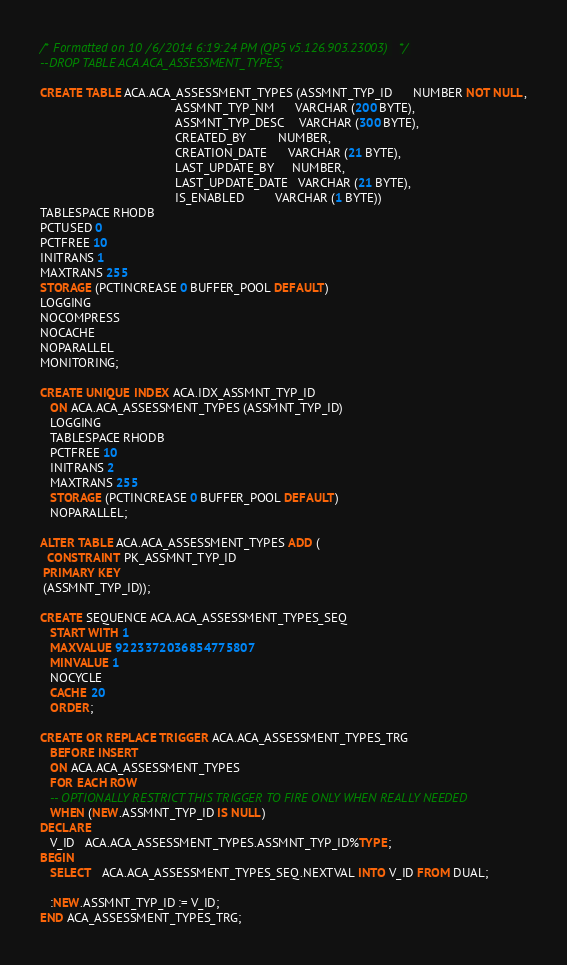<code> <loc_0><loc_0><loc_500><loc_500><_SQL_>/* Formatted on 10/6/2014 6:19:24 PM (QP5 v5.126.903.23003) */
--DROP TABLE ACA.ACA_ASSESSMENT_TYPES;

CREATE TABLE ACA.ACA_ASSESSMENT_TYPES (ASSMNT_TYP_ID      NUMBER NOT NULL,
                                       ASSMNT_TYP_NM      VARCHAR (200 BYTE),
                                       ASSMNT_TYP_DESC    VARCHAR (300 BYTE),
                                       CREATED_BY         NUMBER,
                                       CREATION_DATE      VARCHAR (21 BYTE),
                                       LAST_UPDATE_BY     NUMBER,
                                       LAST_UPDATE_DATE   VARCHAR (21 BYTE),
                                       IS_ENABLED         VARCHAR (1 BYTE))
TABLESPACE RHODB
PCTUSED 0
PCTFREE 10
INITRANS 1
MAXTRANS 255
STORAGE (PCTINCREASE 0 BUFFER_POOL DEFAULT)
LOGGING
NOCOMPRESS
NOCACHE
NOPARALLEL
MONITORING;

CREATE UNIQUE INDEX ACA.IDX_ASSMNT_TYP_ID
   ON ACA.ACA_ASSESSMENT_TYPES (ASSMNT_TYP_ID)
   LOGGING
   TABLESPACE RHODB
   PCTFREE 10
   INITRANS 2
   MAXTRANS 255
   STORAGE (PCTINCREASE 0 BUFFER_POOL DEFAULT)
   NOPARALLEL;

ALTER TABLE ACA.ACA_ASSESSMENT_TYPES ADD (
  CONSTRAINT PK_ASSMNT_TYP_ID
 PRIMARY KEY
 (ASSMNT_TYP_ID));

CREATE SEQUENCE ACA.ACA_ASSESSMENT_TYPES_SEQ
   START WITH 1
   MAXVALUE 9223372036854775807
   MINVALUE 1
   NOCYCLE
   CACHE 20
   ORDER;

CREATE OR REPLACE TRIGGER ACA.ACA_ASSESSMENT_TYPES_TRG
   BEFORE INSERT
   ON ACA.ACA_ASSESSMENT_TYPES
   FOR EACH ROW
   -- OPTIONALLY RESTRICT THIS TRIGGER TO FIRE ONLY WHEN REALLY NEEDED
   WHEN (NEW.ASSMNT_TYP_ID IS NULL)
DECLARE
   V_ID   ACA.ACA_ASSESSMENT_TYPES.ASSMNT_TYP_ID%TYPE;
BEGIN
   SELECT   ACA.ACA_ASSESSMENT_TYPES_SEQ.NEXTVAL INTO V_ID FROM DUAL;

   :NEW.ASSMNT_TYP_ID := V_ID;
END ACA_ASSESSMENT_TYPES_TRG;</code> 